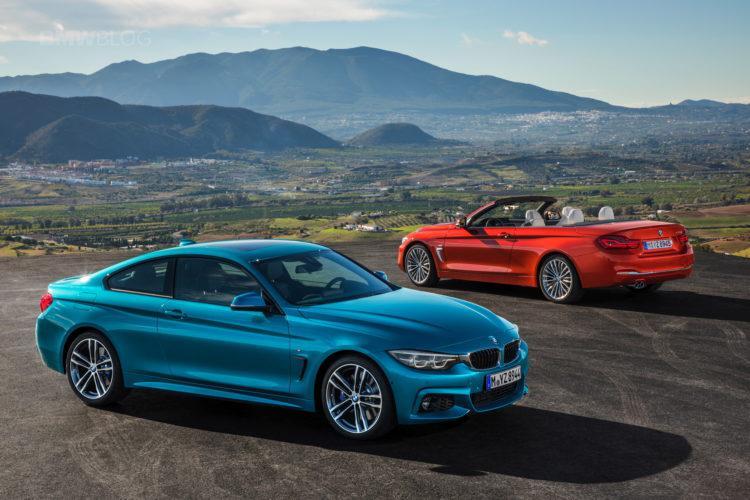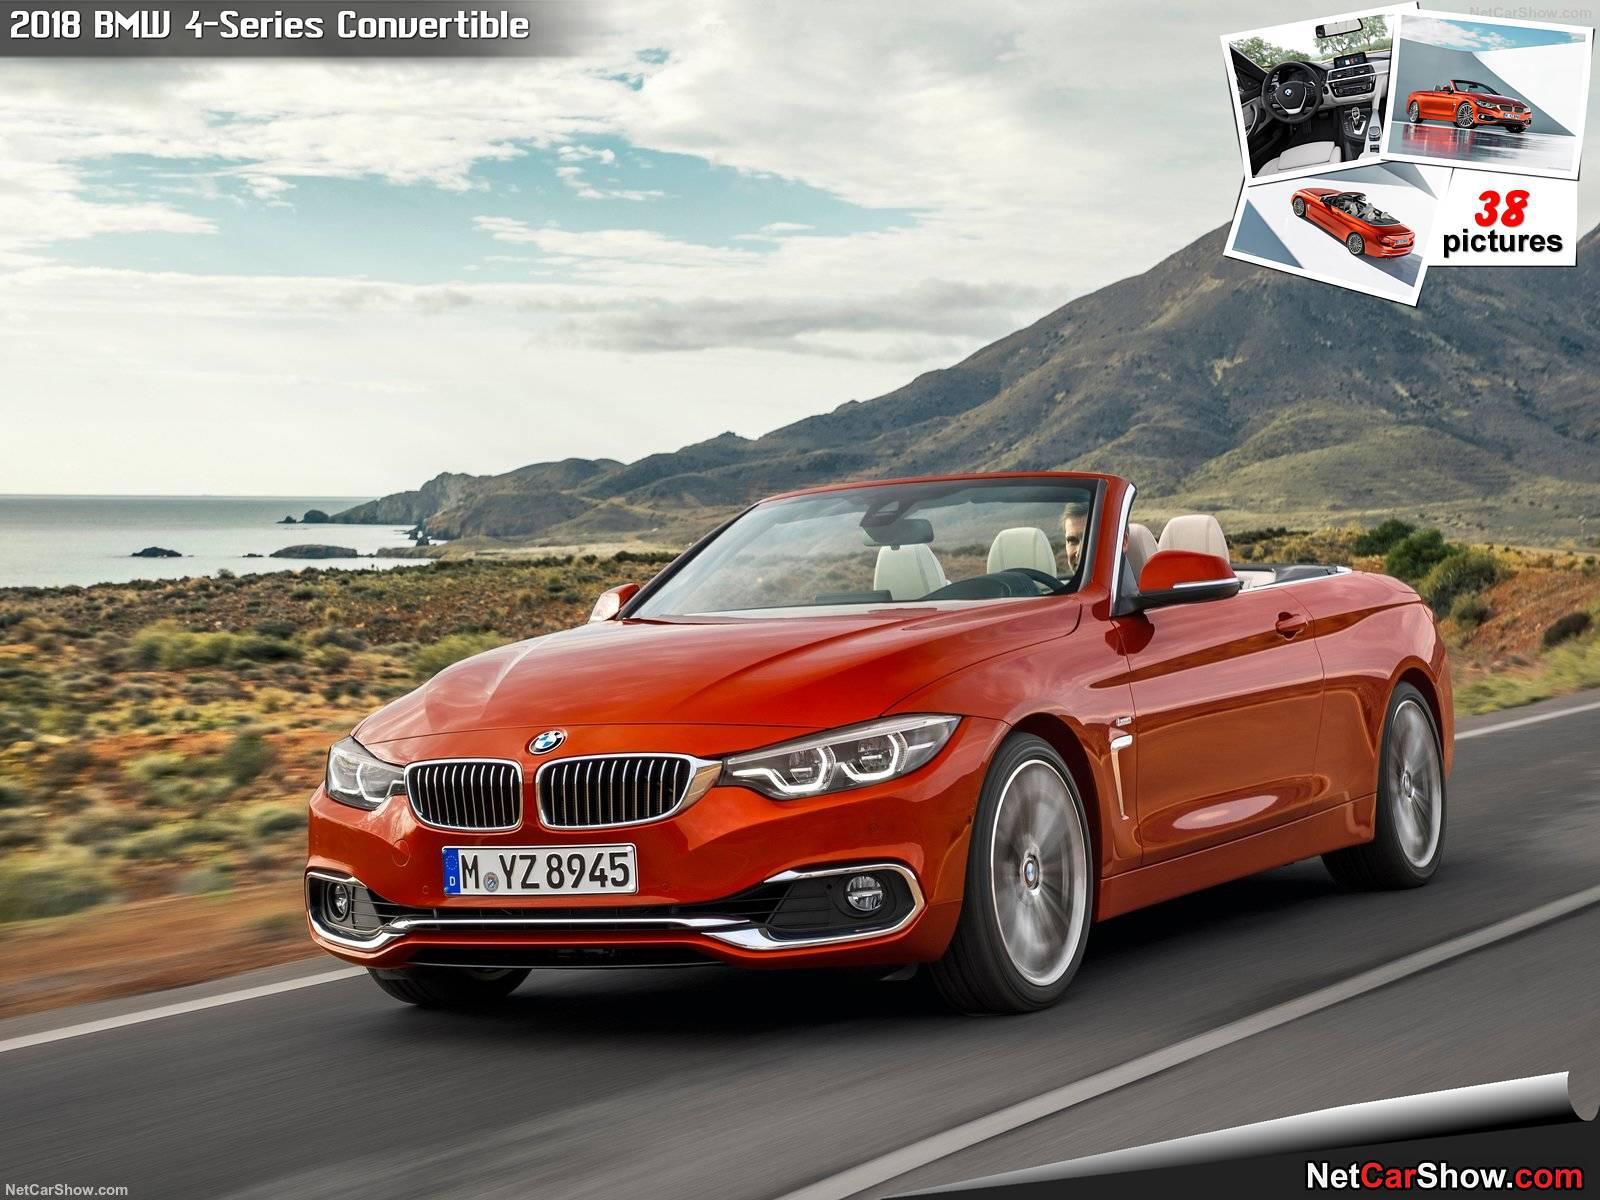The first image is the image on the left, the second image is the image on the right. Examine the images to the left and right. Is the description "One image features a red convertible and a blue car with a top, and the vehicles face opposite directions." accurate? Answer yes or no. Yes. The first image is the image on the left, the second image is the image on the right. For the images shown, is this caption "The left hand image shows one red and one blue car, while the right hand image shows exactly one red convertible vehicle." true? Answer yes or no. Yes. 